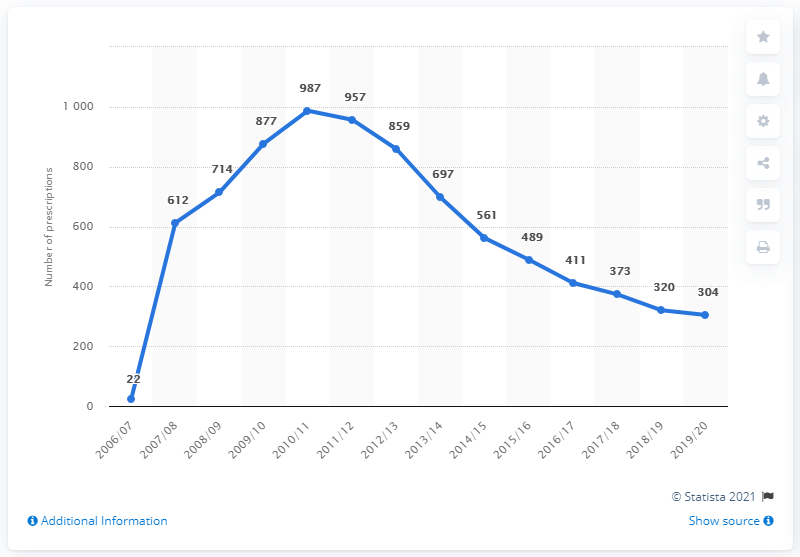Highlight a few significant elements in this photo. The highest data point is 987. The biggest change in prescription numbers across all years is 590. 